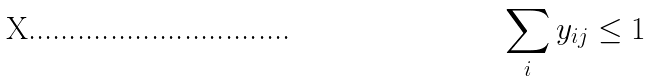<formula> <loc_0><loc_0><loc_500><loc_500>\sum _ { i } y _ { i j } \leq 1</formula> 